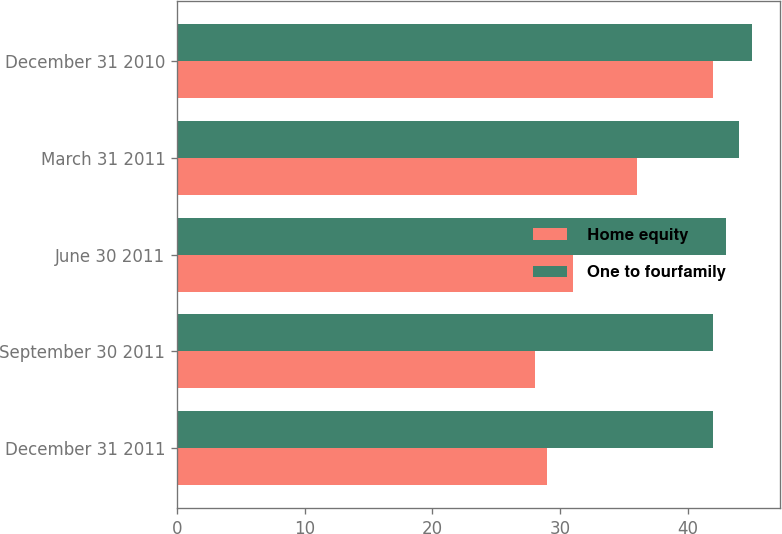Convert chart. <chart><loc_0><loc_0><loc_500><loc_500><stacked_bar_chart><ecel><fcel>December 31 2011<fcel>September 30 2011<fcel>June 30 2011<fcel>March 31 2011<fcel>December 31 2010<nl><fcel>Home equity<fcel>29<fcel>28<fcel>31<fcel>36<fcel>42<nl><fcel>One to fourfamily<fcel>42<fcel>42<fcel>43<fcel>44<fcel>45<nl></chart> 